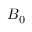Convert formula to latex. <formula><loc_0><loc_0><loc_500><loc_500>B _ { 0 }</formula> 